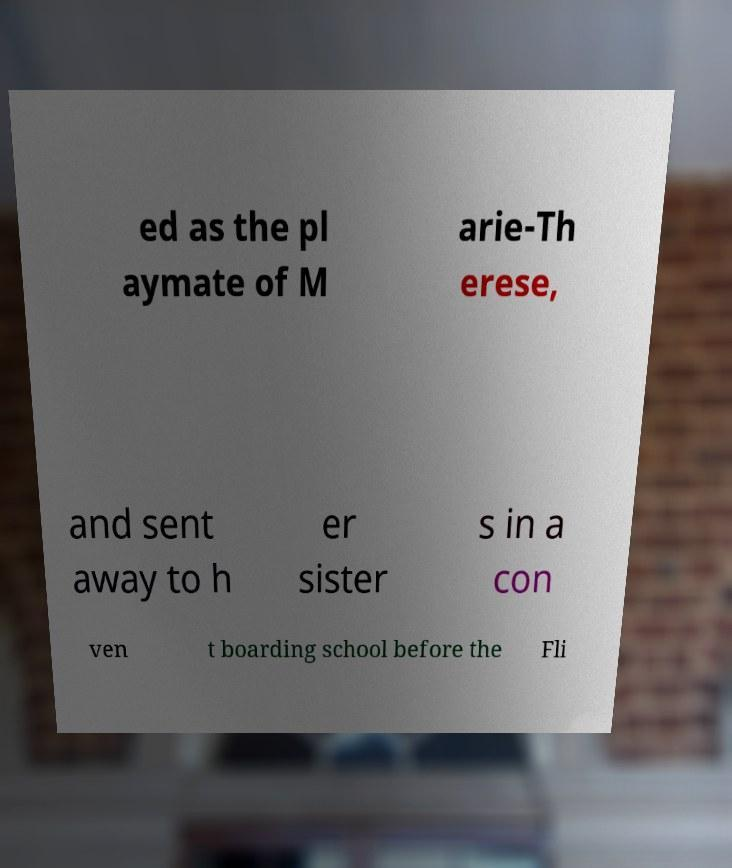Please read and relay the text visible in this image. What does it say? ed as the pl aymate of M arie-Th erese, and sent away to h er sister s in a con ven t boarding school before the Fli 